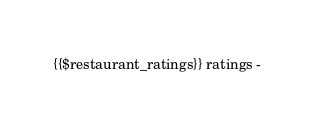<code> <loc_0><loc_0><loc_500><loc_500><_PHP_>{{$restaurant_ratings}} ratings -
</code> 